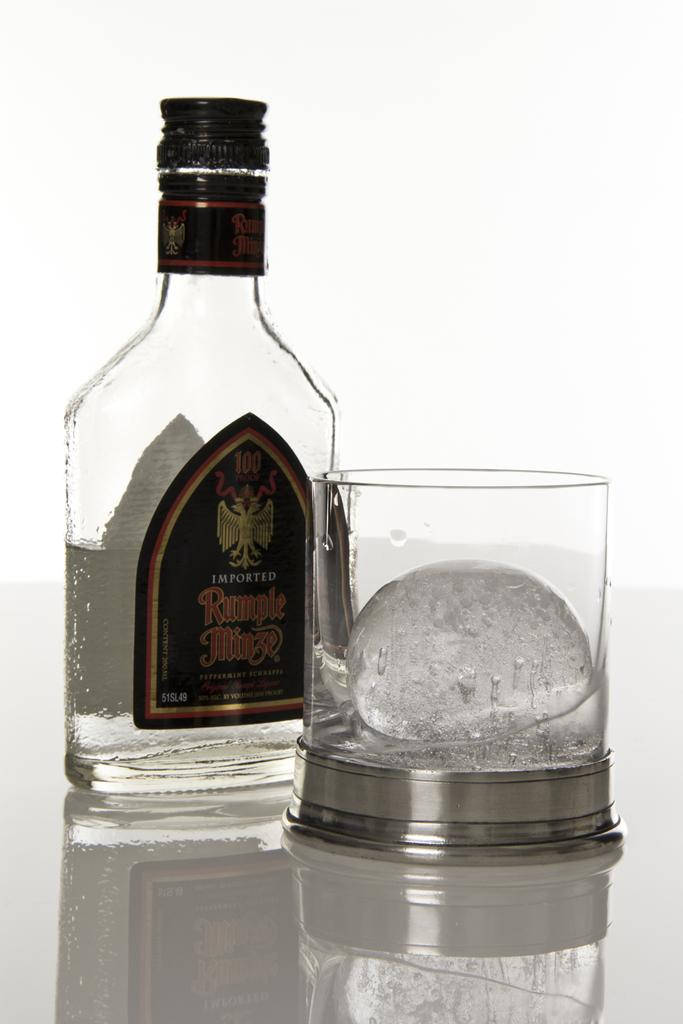What is on the table in the image? There is a bottle and a glass with ice cubes on the table. Can you describe the glass in more detail? The glass has ice cubes in it. What invention is being demonstrated in the image? There is no invention being demonstrated in the image; it simply shows a bottle and a glass with ice cubes on a table. 